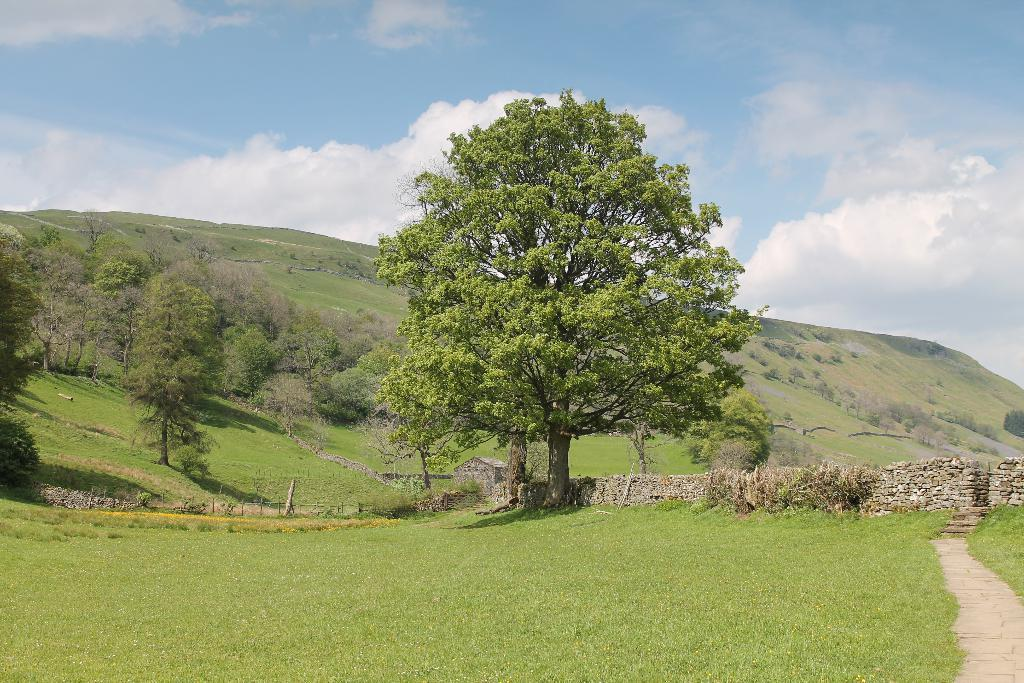What type of vegetation can be seen in the image? There is grass, plants, and trees in the image. What structures are present in the image? There is a wall and a house in the image. What is visible in the background of the image? In the background, there is a hill and the sky. What can be seen in the sky? Clouds are present in the sky. How many stones can be seen in the image? There are no stones present in the image. What type of snake can be seen in the image? There are no snakes present in the image. 